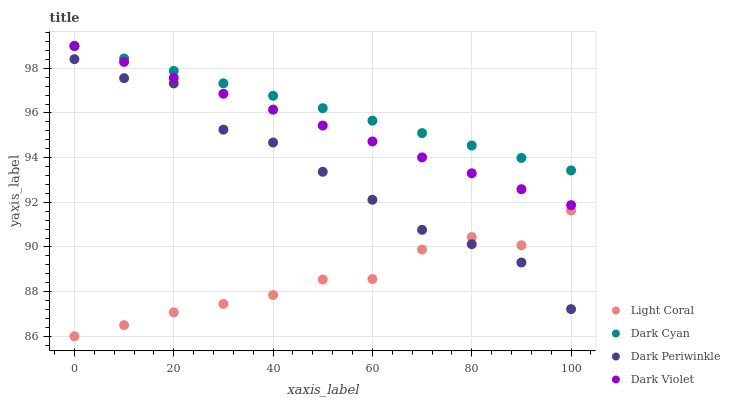Does Light Coral have the minimum area under the curve?
Answer yes or no. Yes. Does Dark Cyan have the maximum area under the curve?
Answer yes or no. Yes. Does Dark Periwinkle have the minimum area under the curve?
Answer yes or no. No. Does Dark Periwinkle have the maximum area under the curve?
Answer yes or no. No. Is Dark Violet the smoothest?
Answer yes or no. Yes. Is Dark Periwinkle the roughest?
Answer yes or no. Yes. Is Dark Cyan the smoothest?
Answer yes or no. No. Is Dark Cyan the roughest?
Answer yes or no. No. Does Light Coral have the lowest value?
Answer yes or no. Yes. Does Dark Periwinkle have the lowest value?
Answer yes or no. No. Does Dark Violet have the highest value?
Answer yes or no. Yes. Does Dark Periwinkle have the highest value?
Answer yes or no. No. Is Dark Periwinkle less than Dark Cyan?
Answer yes or no. Yes. Is Dark Cyan greater than Light Coral?
Answer yes or no. Yes. Does Light Coral intersect Dark Periwinkle?
Answer yes or no. Yes. Is Light Coral less than Dark Periwinkle?
Answer yes or no. No. Is Light Coral greater than Dark Periwinkle?
Answer yes or no. No. Does Dark Periwinkle intersect Dark Cyan?
Answer yes or no. No. 